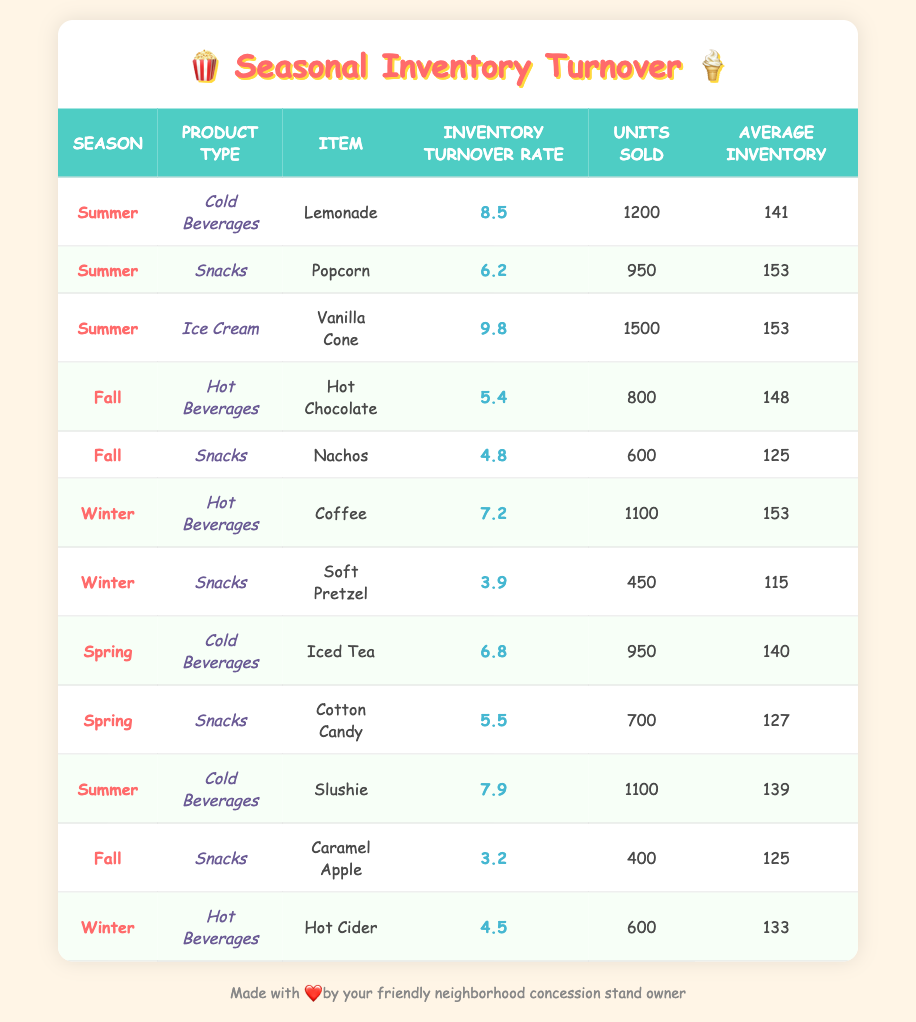What is the highest inventory turnover rate among all items? The highest inventory turnover rate in the table is found by scanning through the 'Inventory Turnover Rate' column. The highest value listed is 9.8 for the item "Vanilla Cone" in Summer.
Answer: 9.8 What product type had the lowest average inventory in Winter? To find the product type with the lowest average inventory in Winter, we look at the 'Average Inventory' column for items listed under the Winter season. The item "Soft Pretzel" has the lowest average inventory at 115.
Answer: Snacks How many units of Iced Tea were sold? The number of units sold for Iced Tea can be directly found in the 'Units Sold' column under the entry for Spring and Cold Beverages. The number listed is 950.
Answer: 950 What is the average inventory turnover rate for Cold Beverages across all seasons? To calculate the average inventory turnover rate for Cold Beverages, we identify the turnover rates for Lemonade (8.5), Iced Tea (6.8), and Slushie (7.9), then we sum them: 8.5 + 6.8 + 7.9 = 23.2. Dividing this total by 3 gives an average of 23.2 / 3 = 7.73.
Answer: 7.73 Is it true that Hot Chocolate has a higher turnover rate than Coffee? We need to compare the turnover rates listed for Hot Chocolate (5.4 in Fall) and Coffee (7.2 in Winter). Since 5.4 is less than 7.2, the statement is false.
Answer: No What season has the highest total units sold when combining all products? We find the total units sold per season: Summer (1200 + 950 + 1500 + 1100 = 3850), Fall (800 + 600 + 400 = 1800), Winter (1100 + 450 + 600 = 2150), and Spring (950 + 700 = 1650). The highest sum is Summer with 3850 units sold.
Answer: Summer What is the inventory turnover rate difference between the highest and lowest rated snacks? From the table, the snack with the highest turnover rate is Popcorn (6.2), and the lowest is Caramel Apple (3.2). The difference is calculated by subtracting the lower rate from the higher rate: 6.2 - 3.2 = 3.0.
Answer: 3.0 What item sold the least units in Fall? The item with the least units sold in Fall can be found by examining the 'Units Sold' column for Fall. "Caramel Apple" sold the least at 400 units.
Answer: Caramel Apple 